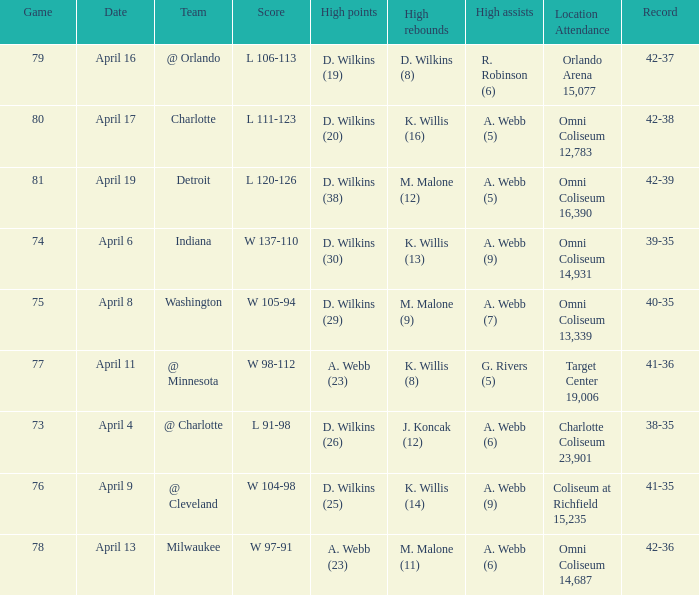How many people had the high points when a. webb (7) had the high assists? 1.0. 